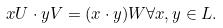Convert formula to latex. <formula><loc_0><loc_0><loc_500><loc_500>x U \cdot y V = ( x \cdot y ) W \forall x , y \in L .</formula> 